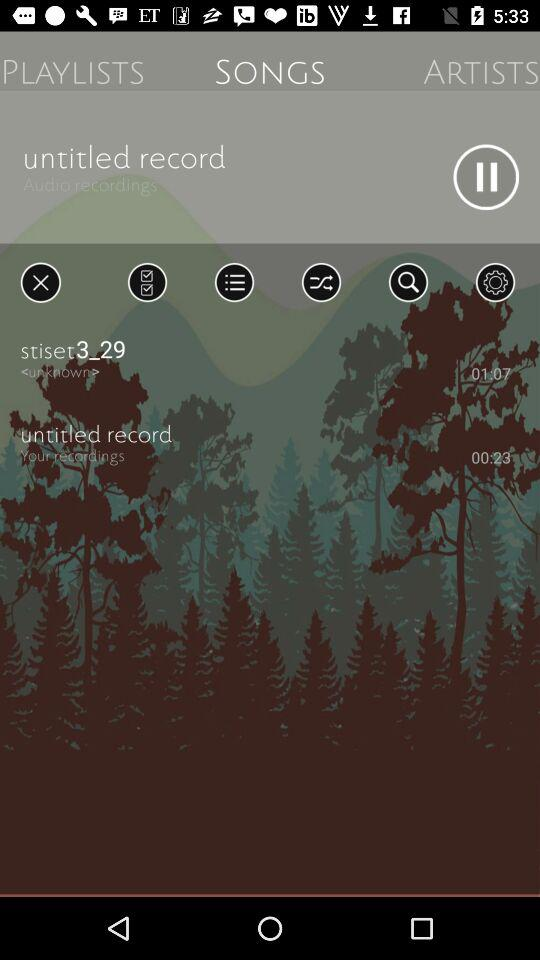Which tab is selected? The selected tab is "SONGS". 